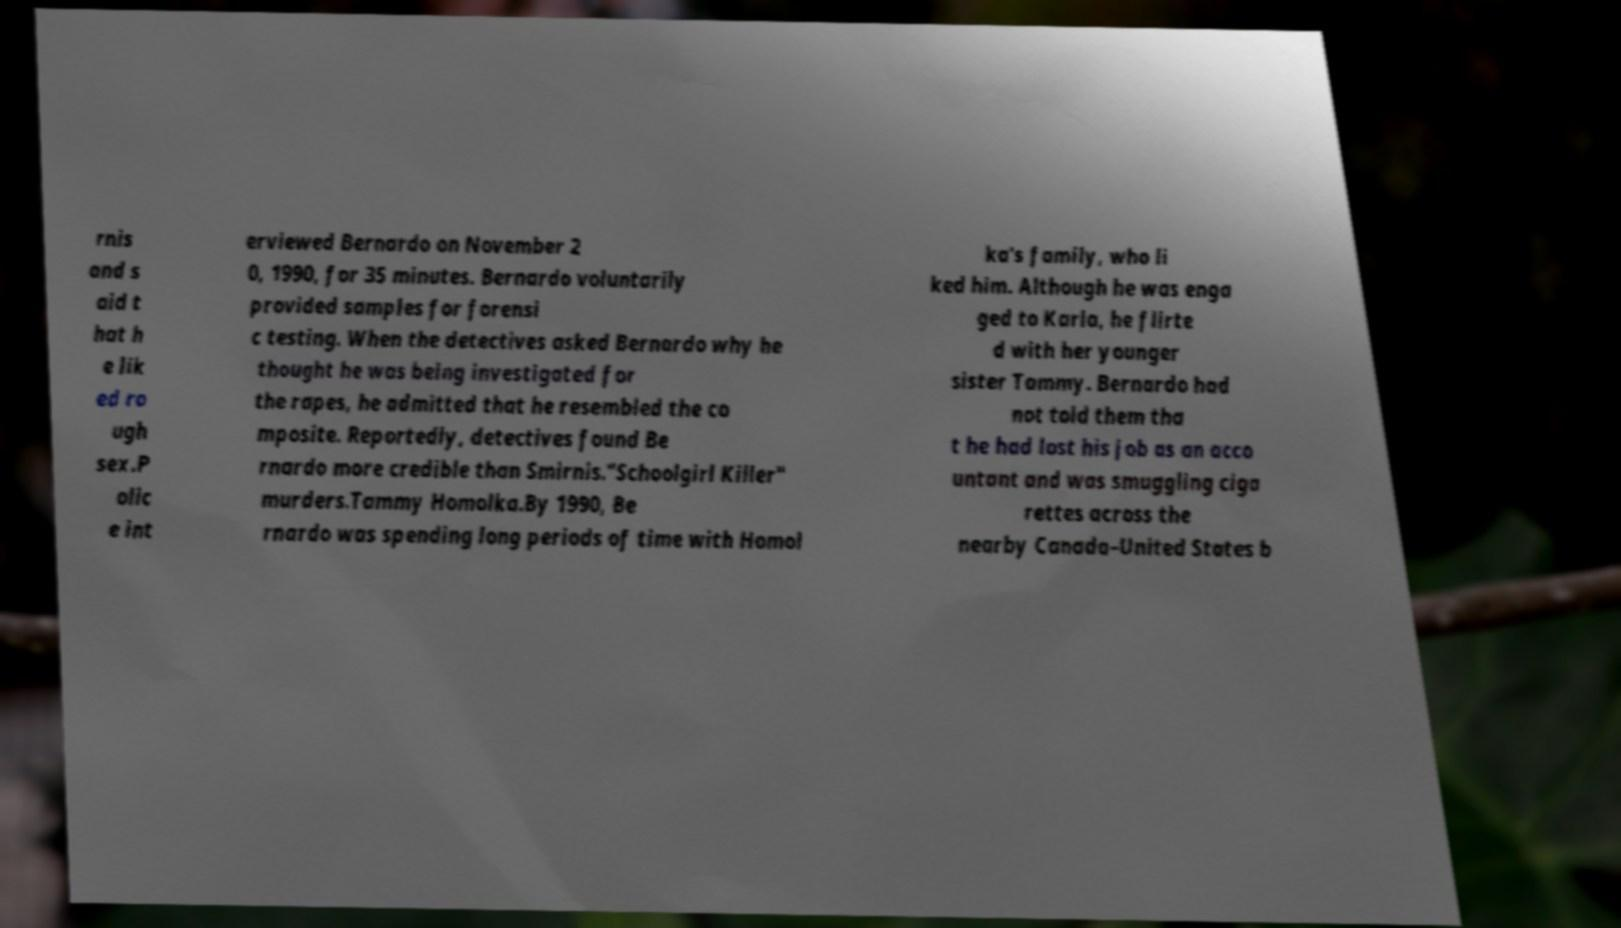I need the written content from this picture converted into text. Can you do that? rnis and s aid t hat h e lik ed ro ugh sex.P olic e int erviewed Bernardo on November 2 0, 1990, for 35 minutes. Bernardo voluntarily provided samples for forensi c testing. When the detectives asked Bernardo why he thought he was being investigated for the rapes, he admitted that he resembled the co mposite. Reportedly, detectives found Be rnardo more credible than Smirnis."Schoolgirl Killer" murders.Tammy Homolka.By 1990, Be rnardo was spending long periods of time with Homol ka's family, who li ked him. Although he was enga ged to Karla, he flirte d with her younger sister Tammy. Bernardo had not told them tha t he had lost his job as an acco untant and was smuggling ciga rettes across the nearby Canada–United States b 